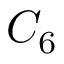Convert formula to latex. <formula><loc_0><loc_0><loc_500><loc_500>C _ { 6 }</formula> 